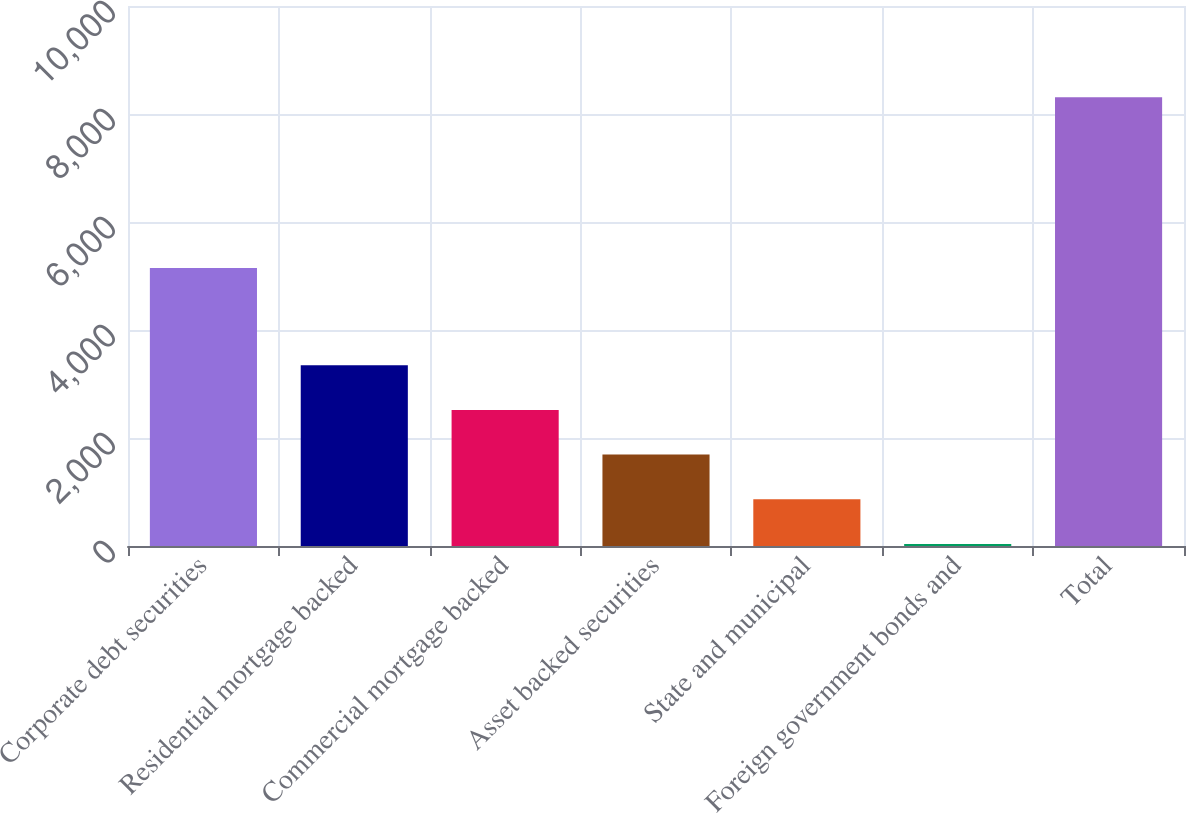Convert chart. <chart><loc_0><loc_0><loc_500><loc_500><bar_chart><fcel>Corporate debt securities<fcel>Residential mortgage backed<fcel>Commercial mortgage backed<fcel>Asset backed securities<fcel>State and municipal<fcel>Foreign government bonds and<fcel>Total<nl><fcel>5150<fcel>3346.6<fcel>2519.7<fcel>1692.8<fcel>865.9<fcel>39<fcel>8308<nl></chart> 